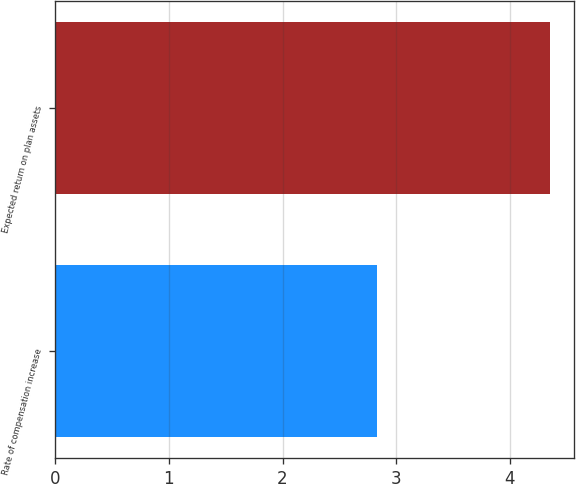Convert chart. <chart><loc_0><loc_0><loc_500><loc_500><bar_chart><fcel>Rate of compensation increase<fcel>Expected return on plan assets<nl><fcel>2.83<fcel>4.35<nl></chart> 